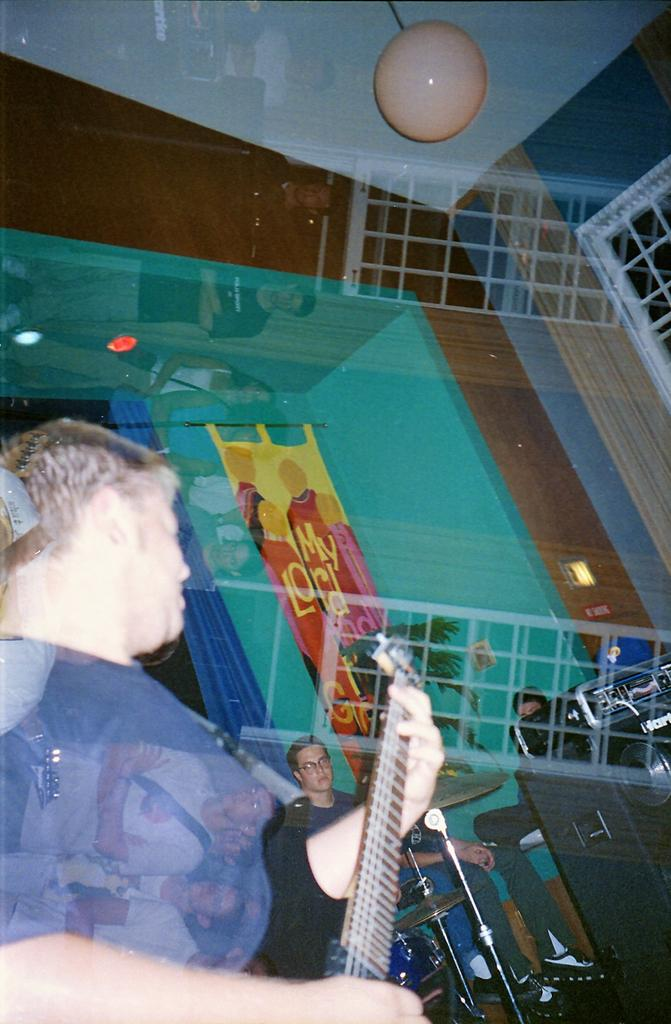What type of structure can be seen in the image? There is a wall in the image. Is there any opening in the wall? Yes, there is a window in the image. What is the man in the image doing? The man is holding a guitar in the image. What type of jelly can be seen on the wall in the image? There is no jelly present on the wall in the image. How does the earth appear in the image? The image does not depict the earth; it only shows a wall, a window, and a man holding a guitar. 